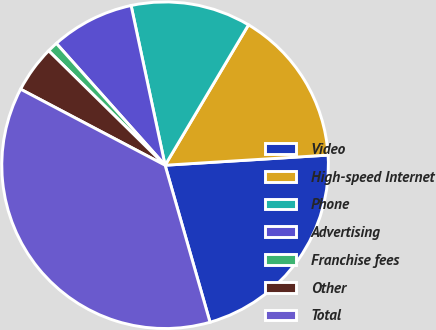Convert chart to OTSL. <chart><loc_0><loc_0><loc_500><loc_500><pie_chart><fcel>Video<fcel>High-speed Internet<fcel>Phone<fcel>Advertising<fcel>Franchise fees<fcel>Other<fcel>Total<nl><fcel>21.55%<fcel>15.48%<fcel>11.87%<fcel>8.26%<fcel>1.04%<fcel>4.65%<fcel>37.15%<nl></chart> 